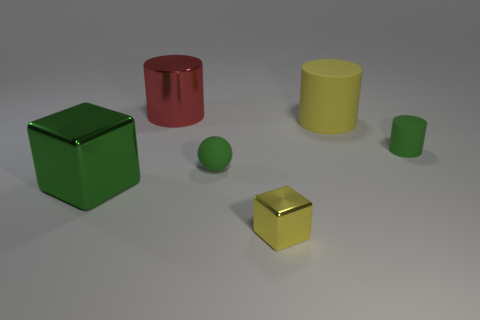Can you describe the different colors and shapes of the objects in this scene? Certainly! In this scene, there are two cylindrical objects, one red and one yellow, and two cubic objects, one green and one yellow. Additionally, there are two spherical objects, one smaller and green and the other larger and yellow. The shapes are simple and the colors are distinct, creating a visually clear differentiation between each item. 